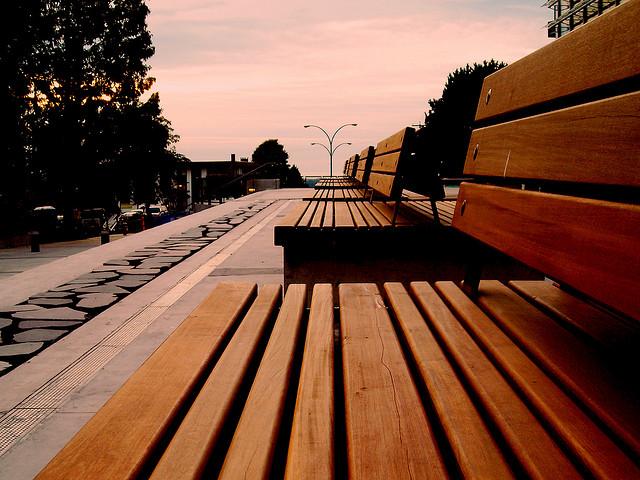What is the bench made of?
Write a very short answer. Wood. What color are the clouds in the sky?
Give a very brief answer. Pink. How many narrow beams make up one bench?
Concise answer only. 6. Why are the benches there?
Quick response, please. To sit on. 